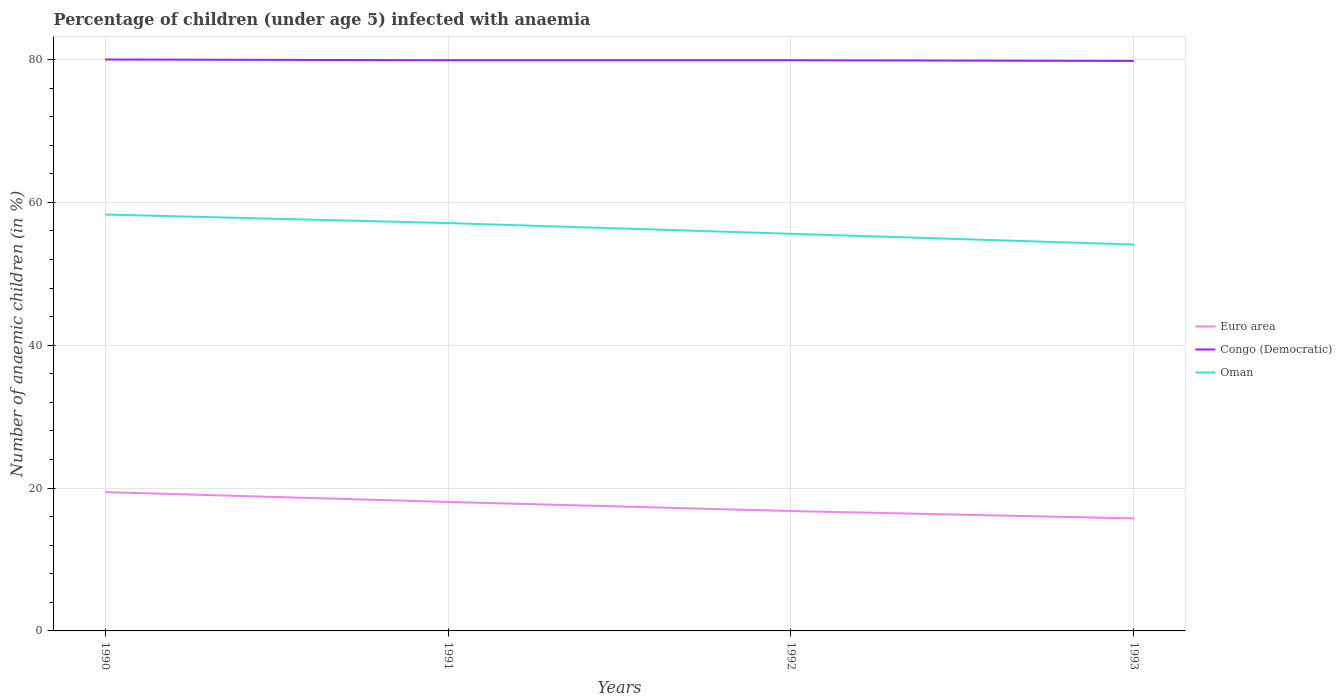Does the line corresponding to Euro area intersect with the line corresponding to Oman?
Offer a very short reply. No. Is the number of lines equal to the number of legend labels?
Your answer should be very brief. Yes. Across all years, what is the maximum percentage of children infected with anaemia in in Euro area?
Provide a short and direct response. 15.75. In which year was the percentage of children infected with anaemia in in Euro area maximum?
Give a very brief answer. 1993. What is the total percentage of children infected with anaemia in in Oman in the graph?
Your answer should be very brief. 2.7. What is the difference between the highest and the second highest percentage of children infected with anaemia in in Euro area?
Your answer should be compact. 3.68. What is the difference between the highest and the lowest percentage of children infected with anaemia in in Congo (Democratic)?
Offer a very short reply. 1. Is the percentage of children infected with anaemia in in Euro area strictly greater than the percentage of children infected with anaemia in in Congo (Democratic) over the years?
Make the answer very short. Yes. What is the difference between two consecutive major ticks on the Y-axis?
Make the answer very short. 20. What is the title of the graph?
Keep it short and to the point. Percentage of children (under age 5) infected with anaemia. What is the label or title of the X-axis?
Your response must be concise. Years. What is the label or title of the Y-axis?
Provide a short and direct response. Number of anaemic children (in %). What is the Number of anaemic children (in %) in Euro area in 1990?
Keep it short and to the point. 19.43. What is the Number of anaemic children (in %) in Congo (Democratic) in 1990?
Your response must be concise. 80. What is the Number of anaemic children (in %) of Oman in 1990?
Your answer should be very brief. 58.3. What is the Number of anaemic children (in %) of Euro area in 1991?
Keep it short and to the point. 18.06. What is the Number of anaemic children (in %) in Congo (Democratic) in 1991?
Keep it short and to the point. 79.9. What is the Number of anaemic children (in %) in Oman in 1991?
Keep it short and to the point. 57.1. What is the Number of anaemic children (in %) in Euro area in 1992?
Your response must be concise. 16.78. What is the Number of anaemic children (in %) in Congo (Democratic) in 1992?
Your answer should be very brief. 79.9. What is the Number of anaemic children (in %) in Oman in 1992?
Your response must be concise. 55.6. What is the Number of anaemic children (in %) of Euro area in 1993?
Ensure brevity in your answer.  15.75. What is the Number of anaemic children (in %) of Congo (Democratic) in 1993?
Offer a very short reply. 79.8. What is the Number of anaemic children (in %) of Oman in 1993?
Offer a terse response. 54.1. Across all years, what is the maximum Number of anaemic children (in %) of Euro area?
Your answer should be compact. 19.43. Across all years, what is the maximum Number of anaemic children (in %) of Oman?
Give a very brief answer. 58.3. Across all years, what is the minimum Number of anaemic children (in %) in Euro area?
Provide a succinct answer. 15.75. Across all years, what is the minimum Number of anaemic children (in %) in Congo (Democratic)?
Provide a short and direct response. 79.8. Across all years, what is the minimum Number of anaemic children (in %) in Oman?
Your response must be concise. 54.1. What is the total Number of anaemic children (in %) of Euro area in the graph?
Your response must be concise. 70.03. What is the total Number of anaemic children (in %) of Congo (Democratic) in the graph?
Ensure brevity in your answer.  319.6. What is the total Number of anaemic children (in %) of Oman in the graph?
Give a very brief answer. 225.1. What is the difference between the Number of anaemic children (in %) in Euro area in 1990 and that in 1991?
Make the answer very short. 1.38. What is the difference between the Number of anaemic children (in %) of Euro area in 1990 and that in 1992?
Keep it short and to the point. 2.65. What is the difference between the Number of anaemic children (in %) of Euro area in 1990 and that in 1993?
Ensure brevity in your answer.  3.68. What is the difference between the Number of anaemic children (in %) of Euro area in 1991 and that in 1992?
Make the answer very short. 1.27. What is the difference between the Number of anaemic children (in %) in Congo (Democratic) in 1991 and that in 1992?
Provide a short and direct response. 0. What is the difference between the Number of anaemic children (in %) of Euro area in 1991 and that in 1993?
Give a very brief answer. 2.3. What is the difference between the Number of anaemic children (in %) in Congo (Democratic) in 1991 and that in 1993?
Your response must be concise. 0.1. What is the difference between the Number of anaemic children (in %) of Oman in 1991 and that in 1993?
Make the answer very short. 3. What is the difference between the Number of anaemic children (in %) of Euro area in 1992 and that in 1993?
Your answer should be very brief. 1.03. What is the difference between the Number of anaemic children (in %) of Congo (Democratic) in 1992 and that in 1993?
Your answer should be very brief. 0.1. What is the difference between the Number of anaemic children (in %) of Euro area in 1990 and the Number of anaemic children (in %) of Congo (Democratic) in 1991?
Make the answer very short. -60.47. What is the difference between the Number of anaemic children (in %) of Euro area in 1990 and the Number of anaemic children (in %) of Oman in 1991?
Your answer should be very brief. -37.67. What is the difference between the Number of anaemic children (in %) in Congo (Democratic) in 1990 and the Number of anaemic children (in %) in Oman in 1991?
Make the answer very short. 22.9. What is the difference between the Number of anaemic children (in %) of Euro area in 1990 and the Number of anaemic children (in %) of Congo (Democratic) in 1992?
Provide a short and direct response. -60.47. What is the difference between the Number of anaemic children (in %) in Euro area in 1990 and the Number of anaemic children (in %) in Oman in 1992?
Keep it short and to the point. -36.17. What is the difference between the Number of anaemic children (in %) of Congo (Democratic) in 1990 and the Number of anaemic children (in %) of Oman in 1992?
Make the answer very short. 24.4. What is the difference between the Number of anaemic children (in %) of Euro area in 1990 and the Number of anaemic children (in %) of Congo (Democratic) in 1993?
Your answer should be compact. -60.37. What is the difference between the Number of anaemic children (in %) in Euro area in 1990 and the Number of anaemic children (in %) in Oman in 1993?
Your answer should be compact. -34.67. What is the difference between the Number of anaemic children (in %) of Congo (Democratic) in 1990 and the Number of anaemic children (in %) of Oman in 1993?
Your answer should be compact. 25.9. What is the difference between the Number of anaemic children (in %) in Euro area in 1991 and the Number of anaemic children (in %) in Congo (Democratic) in 1992?
Offer a terse response. -61.84. What is the difference between the Number of anaemic children (in %) of Euro area in 1991 and the Number of anaemic children (in %) of Oman in 1992?
Your response must be concise. -37.54. What is the difference between the Number of anaemic children (in %) of Congo (Democratic) in 1991 and the Number of anaemic children (in %) of Oman in 1992?
Provide a succinct answer. 24.3. What is the difference between the Number of anaemic children (in %) in Euro area in 1991 and the Number of anaemic children (in %) in Congo (Democratic) in 1993?
Your answer should be compact. -61.74. What is the difference between the Number of anaemic children (in %) in Euro area in 1991 and the Number of anaemic children (in %) in Oman in 1993?
Offer a terse response. -36.04. What is the difference between the Number of anaemic children (in %) of Congo (Democratic) in 1991 and the Number of anaemic children (in %) of Oman in 1993?
Your response must be concise. 25.8. What is the difference between the Number of anaemic children (in %) in Euro area in 1992 and the Number of anaemic children (in %) in Congo (Democratic) in 1993?
Your answer should be compact. -63.02. What is the difference between the Number of anaemic children (in %) of Euro area in 1992 and the Number of anaemic children (in %) of Oman in 1993?
Provide a succinct answer. -37.32. What is the difference between the Number of anaemic children (in %) in Congo (Democratic) in 1992 and the Number of anaemic children (in %) in Oman in 1993?
Ensure brevity in your answer.  25.8. What is the average Number of anaemic children (in %) in Euro area per year?
Make the answer very short. 17.51. What is the average Number of anaemic children (in %) in Congo (Democratic) per year?
Your answer should be very brief. 79.9. What is the average Number of anaemic children (in %) in Oman per year?
Offer a very short reply. 56.27. In the year 1990, what is the difference between the Number of anaemic children (in %) in Euro area and Number of anaemic children (in %) in Congo (Democratic)?
Ensure brevity in your answer.  -60.57. In the year 1990, what is the difference between the Number of anaemic children (in %) in Euro area and Number of anaemic children (in %) in Oman?
Provide a short and direct response. -38.87. In the year 1990, what is the difference between the Number of anaemic children (in %) in Congo (Democratic) and Number of anaemic children (in %) in Oman?
Provide a succinct answer. 21.7. In the year 1991, what is the difference between the Number of anaemic children (in %) of Euro area and Number of anaemic children (in %) of Congo (Democratic)?
Give a very brief answer. -61.84. In the year 1991, what is the difference between the Number of anaemic children (in %) in Euro area and Number of anaemic children (in %) in Oman?
Give a very brief answer. -39.04. In the year 1991, what is the difference between the Number of anaemic children (in %) in Congo (Democratic) and Number of anaemic children (in %) in Oman?
Make the answer very short. 22.8. In the year 1992, what is the difference between the Number of anaemic children (in %) of Euro area and Number of anaemic children (in %) of Congo (Democratic)?
Provide a succinct answer. -63.12. In the year 1992, what is the difference between the Number of anaemic children (in %) in Euro area and Number of anaemic children (in %) in Oman?
Your answer should be very brief. -38.82. In the year 1992, what is the difference between the Number of anaemic children (in %) in Congo (Democratic) and Number of anaemic children (in %) in Oman?
Your response must be concise. 24.3. In the year 1993, what is the difference between the Number of anaemic children (in %) in Euro area and Number of anaemic children (in %) in Congo (Democratic)?
Ensure brevity in your answer.  -64.05. In the year 1993, what is the difference between the Number of anaemic children (in %) of Euro area and Number of anaemic children (in %) of Oman?
Your response must be concise. -38.35. In the year 1993, what is the difference between the Number of anaemic children (in %) of Congo (Democratic) and Number of anaemic children (in %) of Oman?
Make the answer very short. 25.7. What is the ratio of the Number of anaemic children (in %) of Euro area in 1990 to that in 1991?
Make the answer very short. 1.08. What is the ratio of the Number of anaemic children (in %) in Euro area in 1990 to that in 1992?
Provide a short and direct response. 1.16. What is the ratio of the Number of anaemic children (in %) in Oman in 1990 to that in 1992?
Ensure brevity in your answer.  1.05. What is the ratio of the Number of anaemic children (in %) in Euro area in 1990 to that in 1993?
Your response must be concise. 1.23. What is the ratio of the Number of anaemic children (in %) in Congo (Democratic) in 1990 to that in 1993?
Provide a succinct answer. 1. What is the ratio of the Number of anaemic children (in %) of Oman in 1990 to that in 1993?
Your response must be concise. 1.08. What is the ratio of the Number of anaemic children (in %) in Euro area in 1991 to that in 1992?
Keep it short and to the point. 1.08. What is the ratio of the Number of anaemic children (in %) in Congo (Democratic) in 1991 to that in 1992?
Give a very brief answer. 1. What is the ratio of the Number of anaemic children (in %) in Euro area in 1991 to that in 1993?
Ensure brevity in your answer.  1.15. What is the ratio of the Number of anaemic children (in %) of Oman in 1991 to that in 1993?
Make the answer very short. 1.06. What is the ratio of the Number of anaemic children (in %) of Euro area in 1992 to that in 1993?
Ensure brevity in your answer.  1.07. What is the ratio of the Number of anaemic children (in %) in Congo (Democratic) in 1992 to that in 1993?
Your answer should be compact. 1. What is the ratio of the Number of anaemic children (in %) in Oman in 1992 to that in 1993?
Keep it short and to the point. 1.03. What is the difference between the highest and the second highest Number of anaemic children (in %) of Euro area?
Keep it short and to the point. 1.38. What is the difference between the highest and the lowest Number of anaemic children (in %) of Euro area?
Make the answer very short. 3.68. What is the difference between the highest and the lowest Number of anaemic children (in %) of Oman?
Offer a terse response. 4.2. 